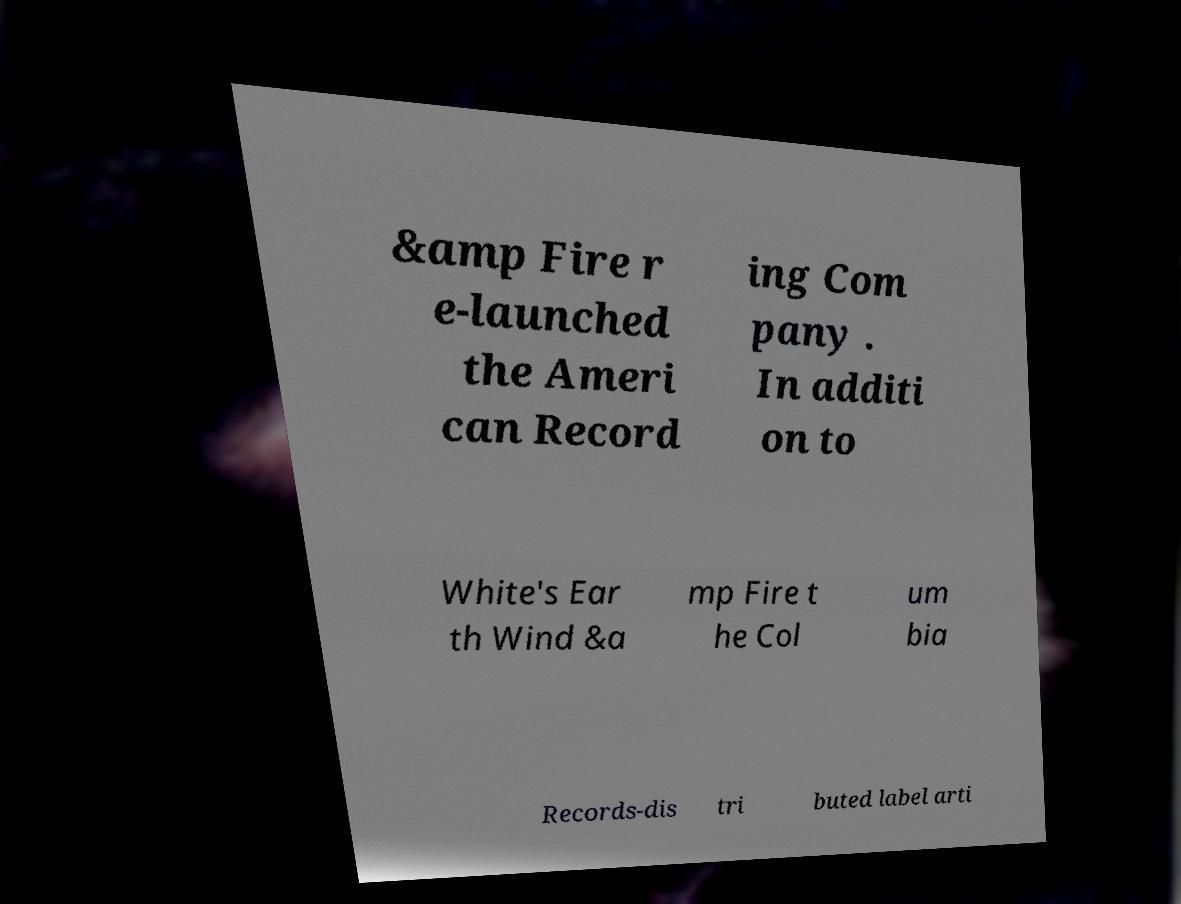Can you accurately transcribe the text from the provided image for me? &amp Fire r e-launched the Ameri can Record ing Com pany . In additi on to White's Ear th Wind &a mp Fire t he Col um bia Records-dis tri buted label arti 